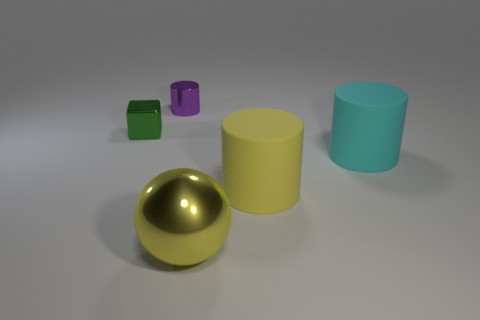Subtract all big rubber cylinders. How many cylinders are left? 1 Subtract all cyan cylinders. How many cylinders are left? 2 Add 2 big yellow metal cubes. How many objects exist? 7 Subtract all cyan cylinders. Subtract all gray cubes. How many cylinders are left? 2 Subtract all blue balls. How many yellow cylinders are left? 1 Subtract all blue cylinders. Subtract all big yellow objects. How many objects are left? 3 Add 3 yellow balls. How many yellow balls are left? 4 Add 5 large cyan metallic spheres. How many large cyan metallic spheres exist? 5 Subtract 0 blue cylinders. How many objects are left? 5 Subtract all spheres. How many objects are left? 4 